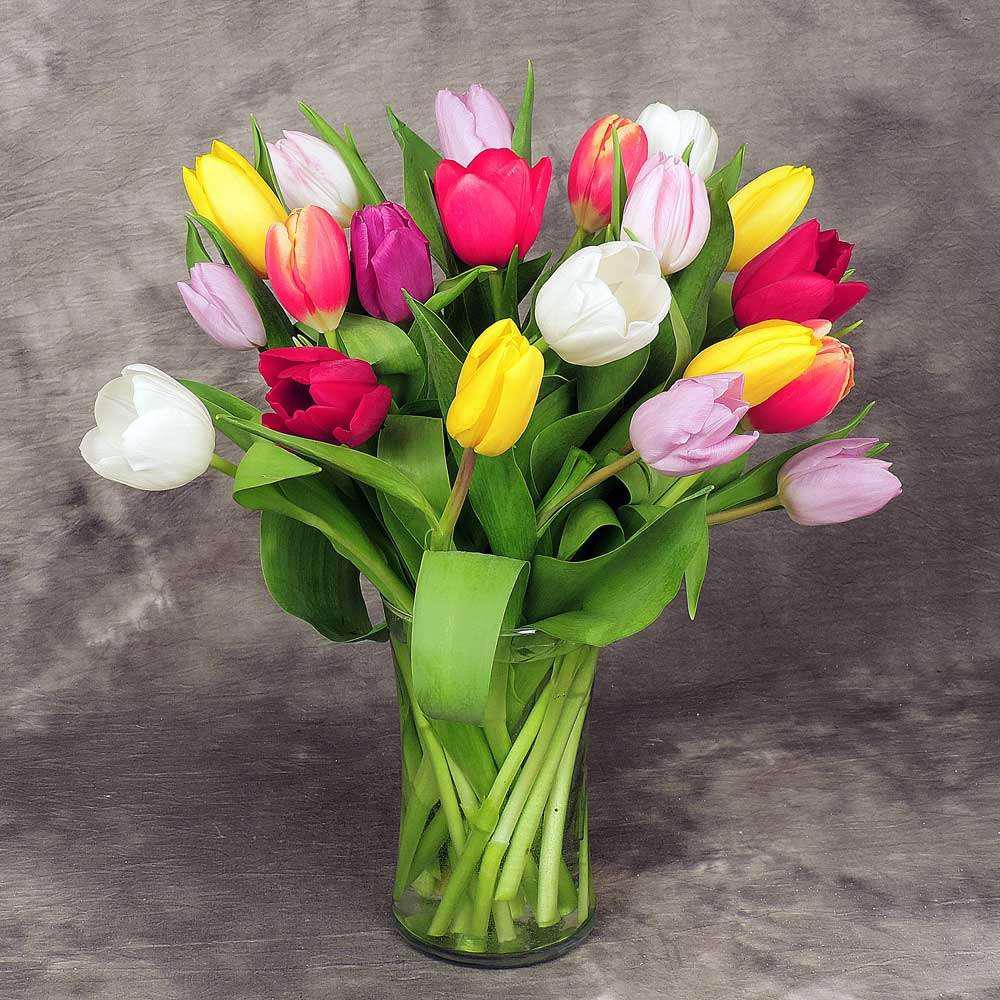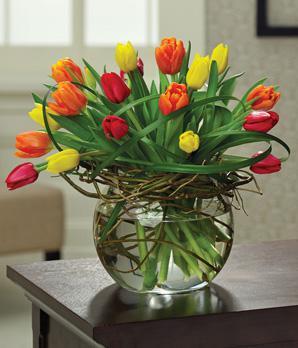The first image is the image on the left, the second image is the image on the right. Assess this claim about the two images: "Each of two vases of multicolored tulips is clear so that the green flower stems are visible, and contains at least three yellow flowers.". Correct or not? Answer yes or no. Yes. The first image is the image on the left, the second image is the image on the right. Given the left and right images, does the statement "Each image features multicolor tulips in a clear glass vase, and one of the vases has a rather spherical shape." hold true? Answer yes or no. Yes. 